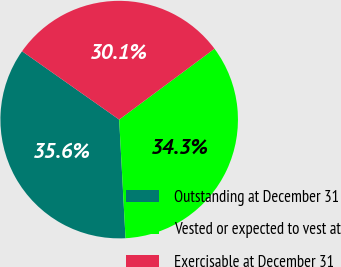<chart> <loc_0><loc_0><loc_500><loc_500><pie_chart><fcel>Outstanding at December 31<fcel>Vested or expected to vest at<fcel>Exercisable at December 31<nl><fcel>35.61%<fcel>34.32%<fcel>30.06%<nl></chart> 